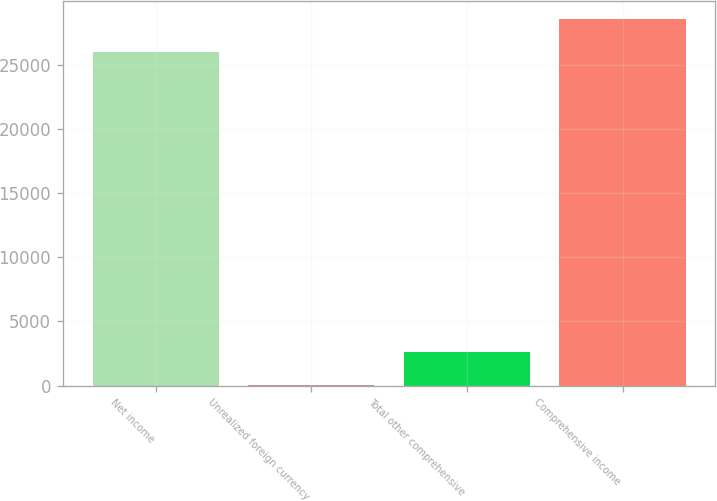<chart> <loc_0><loc_0><loc_500><loc_500><bar_chart><fcel>Net income<fcel>Unrealized foreign currency<fcel>Total other comprehensive<fcel>Comprehensive income<nl><fcel>25963<fcel>46<fcel>2642.3<fcel>28559.3<nl></chart> 